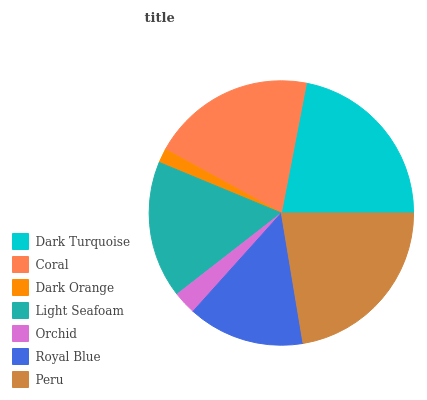Is Dark Orange the minimum?
Answer yes or no. Yes. Is Peru the maximum?
Answer yes or no. Yes. Is Coral the minimum?
Answer yes or no. No. Is Coral the maximum?
Answer yes or no. No. Is Dark Turquoise greater than Coral?
Answer yes or no. Yes. Is Coral less than Dark Turquoise?
Answer yes or no. Yes. Is Coral greater than Dark Turquoise?
Answer yes or no. No. Is Dark Turquoise less than Coral?
Answer yes or no. No. Is Light Seafoam the high median?
Answer yes or no. Yes. Is Light Seafoam the low median?
Answer yes or no. Yes. Is Dark Turquoise the high median?
Answer yes or no. No. Is Dark Orange the low median?
Answer yes or no. No. 